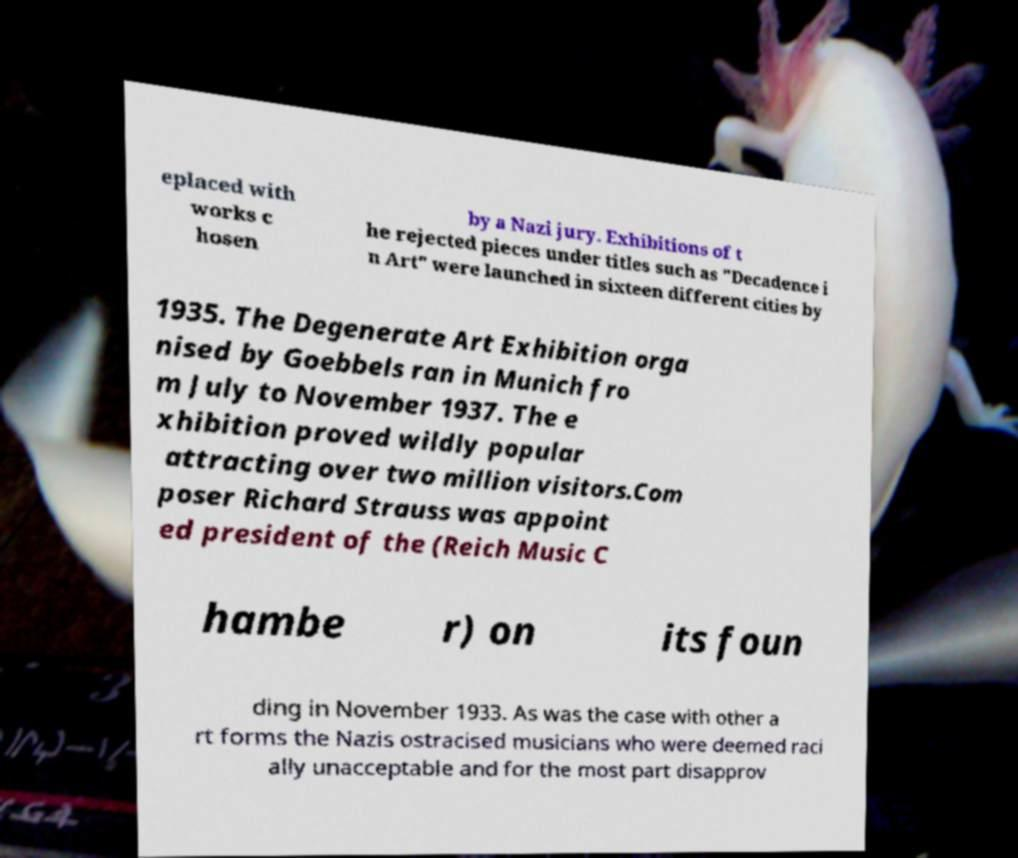Please read and relay the text visible in this image. What does it say? eplaced with works c hosen by a Nazi jury. Exhibitions of t he rejected pieces under titles such as "Decadence i n Art" were launched in sixteen different cities by 1935. The Degenerate Art Exhibition orga nised by Goebbels ran in Munich fro m July to November 1937. The e xhibition proved wildly popular attracting over two million visitors.Com poser Richard Strauss was appoint ed president of the (Reich Music C hambe r) on its foun ding in November 1933. As was the case with other a rt forms the Nazis ostracised musicians who were deemed raci ally unacceptable and for the most part disapprov 